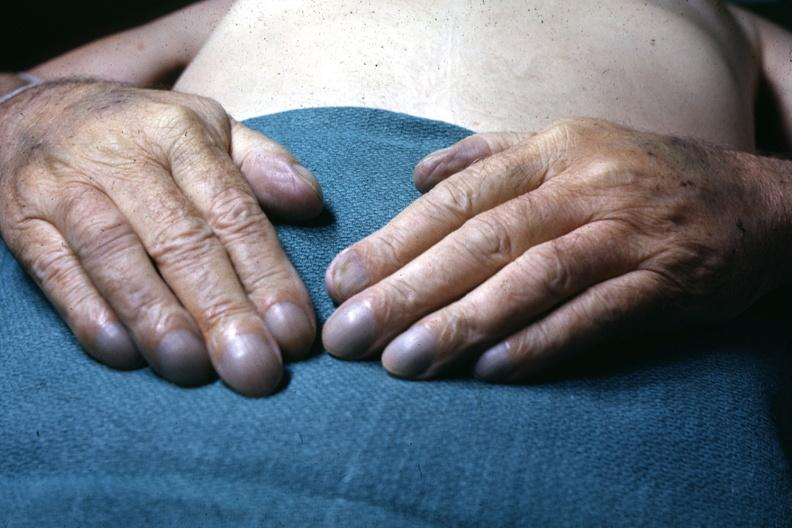does this image show excellent example of pulmonary osteoarthropathy?
Answer the question using a single word or phrase. Yes 